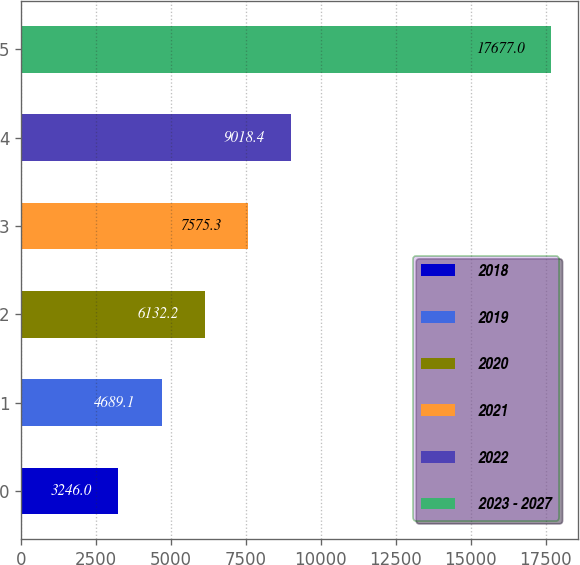Convert chart. <chart><loc_0><loc_0><loc_500><loc_500><bar_chart><fcel>2018<fcel>2019<fcel>2020<fcel>2021<fcel>2022<fcel>2023 - 2027<nl><fcel>3246<fcel>4689.1<fcel>6132.2<fcel>7575.3<fcel>9018.4<fcel>17677<nl></chart> 